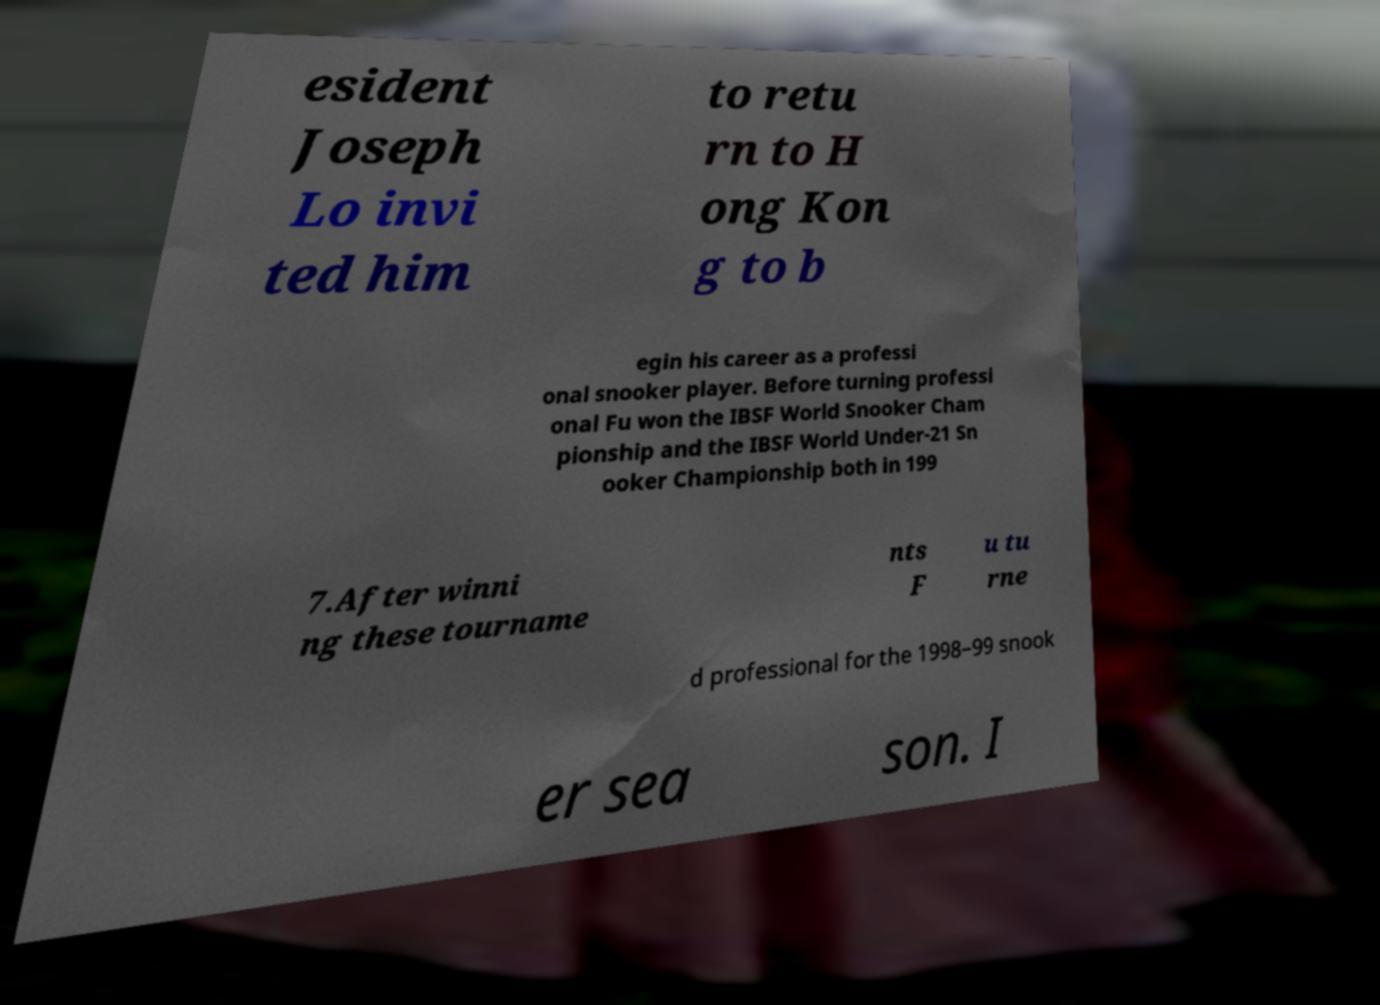Please read and relay the text visible in this image. What does it say? esident Joseph Lo invi ted him to retu rn to H ong Kon g to b egin his career as a professi onal snooker player. Before turning professi onal Fu won the IBSF World Snooker Cham pionship and the IBSF World Under-21 Sn ooker Championship both in 199 7.After winni ng these tourname nts F u tu rne d professional for the 1998–99 snook er sea son. I 